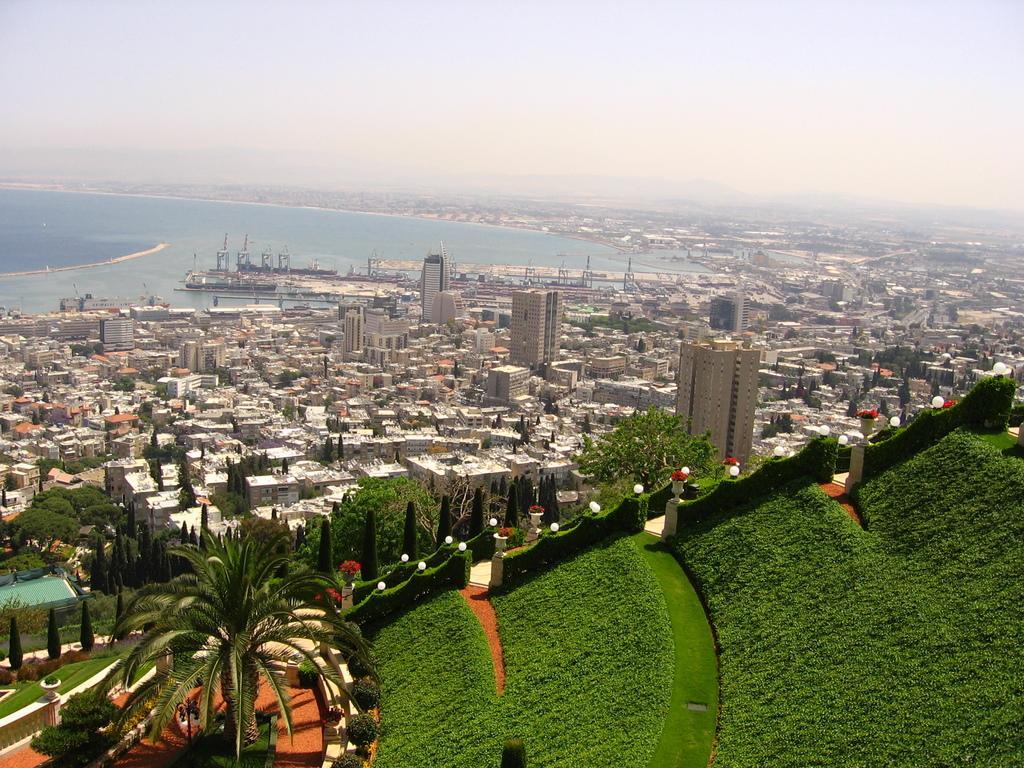Please provide a concise description of this image. This is an outside view. At the bottom of the image I can see a garden. There are many trees and grass. In the middle of the image I can see many buildings. On the left side there is a sea. At the top of the image I can see the sky. 